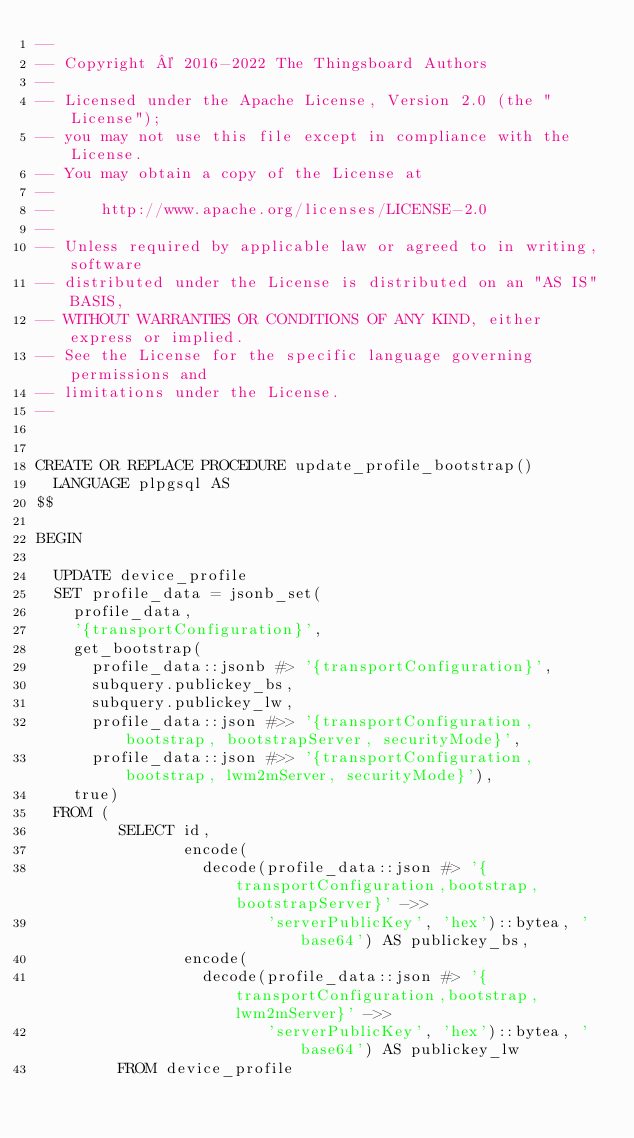<code> <loc_0><loc_0><loc_500><loc_500><_SQL_>--
-- Copyright © 2016-2022 The Thingsboard Authors
--
-- Licensed under the Apache License, Version 2.0 (the "License");
-- you may not use this file except in compliance with the License.
-- You may obtain a copy of the License at
--
--     http://www.apache.org/licenses/LICENSE-2.0
--
-- Unless required by applicable law or agreed to in writing, software
-- distributed under the License is distributed on an "AS IS" BASIS,
-- WITHOUT WARRANTIES OR CONDITIONS OF ANY KIND, either express or implied.
-- See the License for the specific language governing permissions and
-- limitations under the License.
--


CREATE OR REPLACE PROCEDURE update_profile_bootstrap()
  LANGUAGE plpgsql AS
$$

BEGIN

  UPDATE device_profile
  SET profile_data = jsonb_set(
    profile_data,
    '{transportConfiguration}',
    get_bootstrap(
      profile_data::jsonb #> '{transportConfiguration}',
      subquery.publickey_bs,
      subquery.publickey_lw,
      profile_data::json #>> '{transportConfiguration, bootstrap, bootstrapServer, securityMode}',
      profile_data::json #>> '{transportConfiguration, bootstrap, lwm2mServer, securityMode}'),
    true)
  FROM (
         SELECT id,
                encode(
                  decode(profile_data::json #> '{transportConfiguration,bootstrap,bootstrapServer}' ->>
                         'serverPublicKey', 'hex')::bytea, 'base64') AS publickey_bs,
                encode(
                  decode(profile_data::json #> '{transportConfiguration,bootstrap,lwm2mServer}' ->>
                         'serverPublicKey', 'hex')::bytea, 'base64') AS publickey_lw
         FROM device_profile</code> 